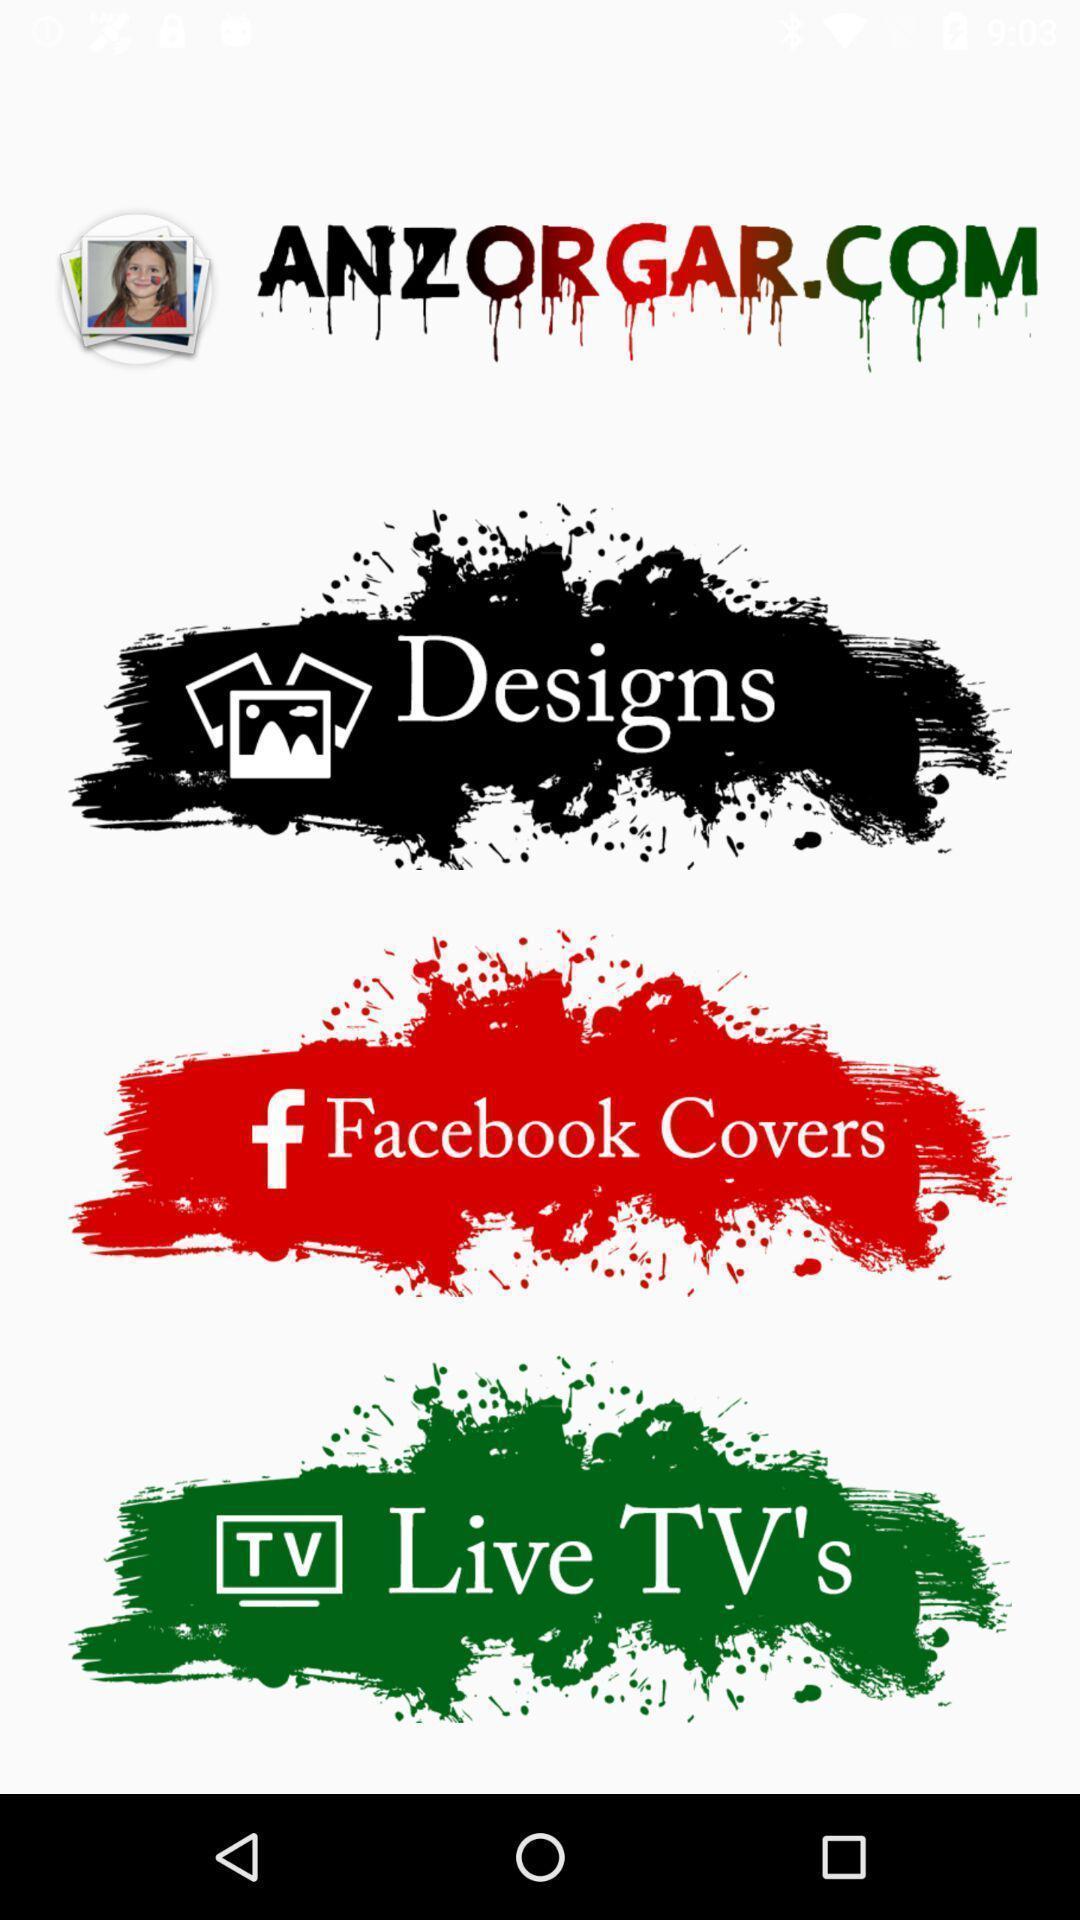What is the overall content of this screenshot? Welcome page. 